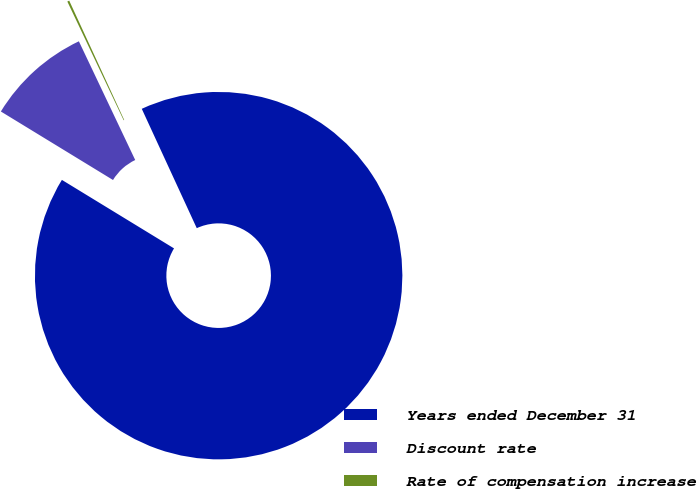Convert chart to OTSL. <chart><loc_0><loc_0><loc_500><loc_500><pie_chart><fcel>Years ended December 31<fcel>Discount rate<fcel>Rate of compensation increase<nl><fcel>90.6%<fcel>9.22%<fcel>0.18%<nl></chart> 